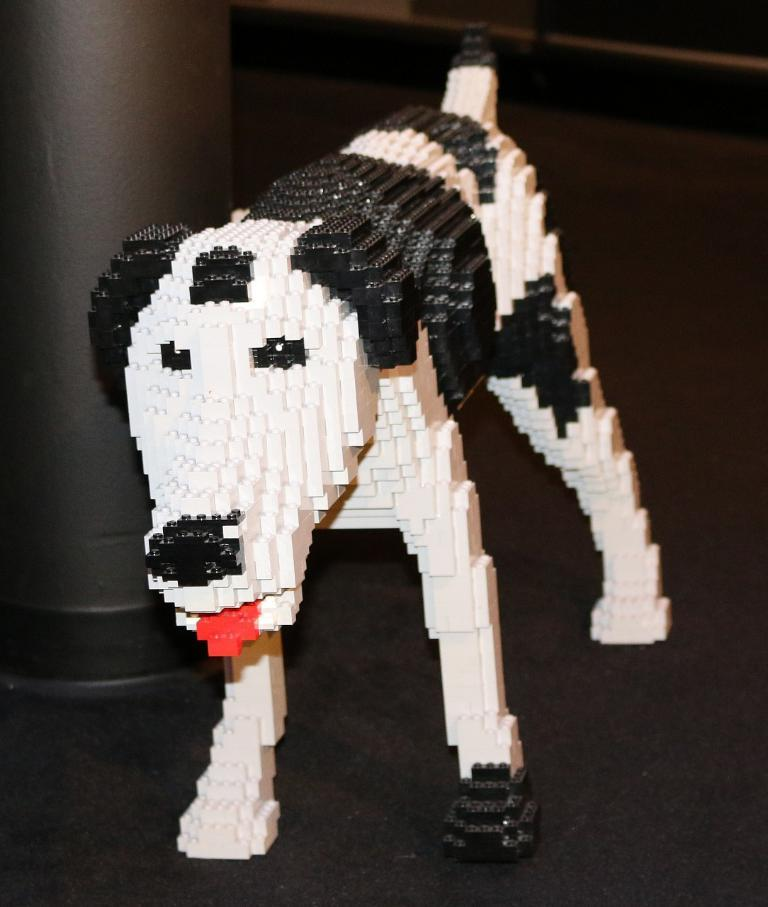What type of animal is present in the image? There is a dog in the image. Can you describe the color pattern of the dog? The dog is black and white colored. What other object can be seen in the image besides the dog? There is a pillar in the image. What type of plant is being raked in the image? There is no plant or rake present in the image; it features a dog and a pillar. 